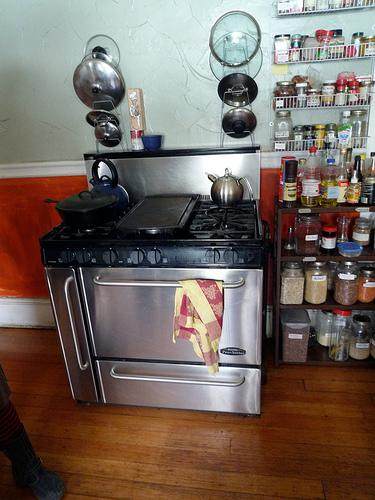Question: what appliance is in the room?
Choices:
A. Dishwasher.
B. Stove.
C. Freezer.
D. Dryer.
Answer with the letter. Answer: B Question: how many tea kettles are there?
Choices:
A. 1.
B. 3.
C. 4.
D. 2.
Answer with the letter. Answer: D Question: what is on the kitchen rack?
Choices:
A. Plates.
B. Pans.
C. Towels.
D. Spices.
Answer with the letter. Answer: D Question: what type of floor is in this room?
Choices:
A. Tile.
B. Wood.
C. Carpet.
D. Brick.
Answer with the letter. Answer: B 